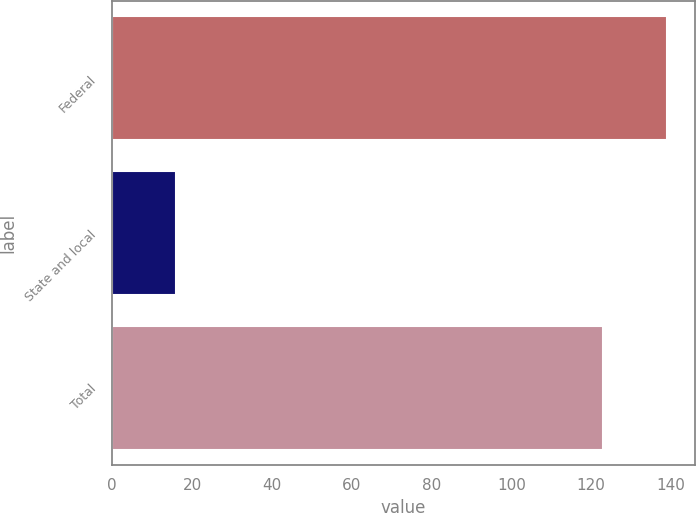Convert chart to OTSL. <chart><loc_0><loc_0><loc_500><loc_500><bar_chart><fcel>Federal<fcel>State and local<fcel>Total<nl><fcel>139<fcel>16<fcel>123<nl></chart> 